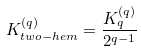<formula> <loc_0><loc_0><loc_500><loc_500>K ^ { ( q ) } _ { t w o - h e m } = \frac { K ^ { ( q ) } _ { q } } { 2 ^ { q - 1 } }</formula> 